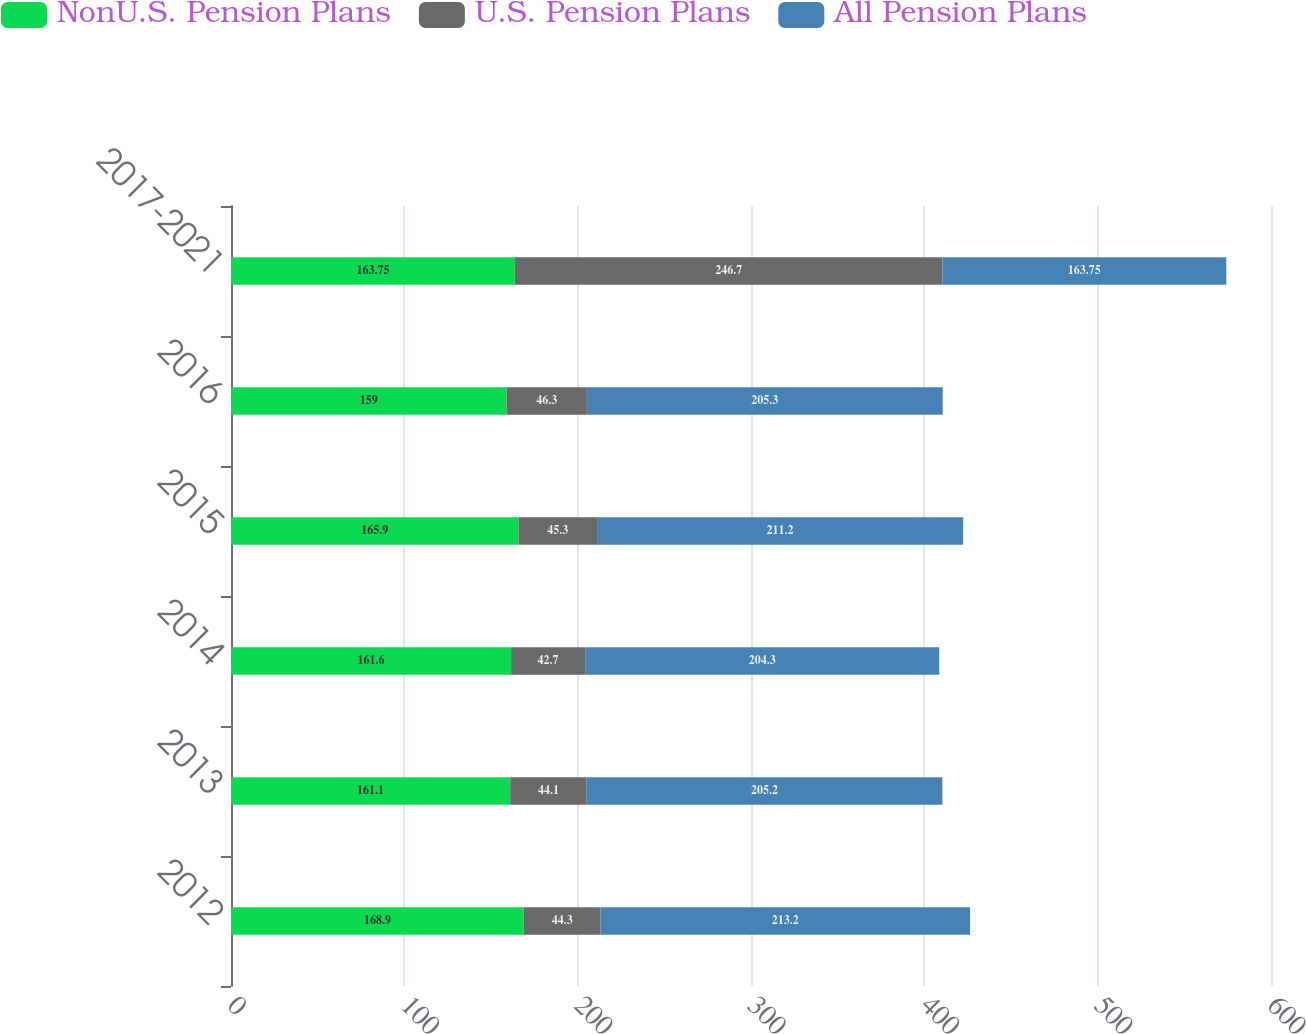Convert chart. <chart><loc_0><loc_0><loc_500><loc_500><stacked_bar_chart><ecel><fcel>2012<fcel>2013<fcel>2014<fcel>2015<fcel>2016<fcel>2017-2021<nl><fcel>NonU.S. Pension Plans<fcel>168.9<fcel>161.1<fcel>161.6<fcel>165.9<fcel>159<fcel>163.75<nl><fcel>U.S. Pension Plans<fcel>44.3<fcel>44.1<fcel>42.7<fcel>45.3<fcel>46.3<fcel>246.7<nl><fcel>All Pension Plans<fcel>213.2<fcel>205.2<fcel>204.3<fcel>211.2<fcel>205.3<fcel>163.75<nl></chart> 